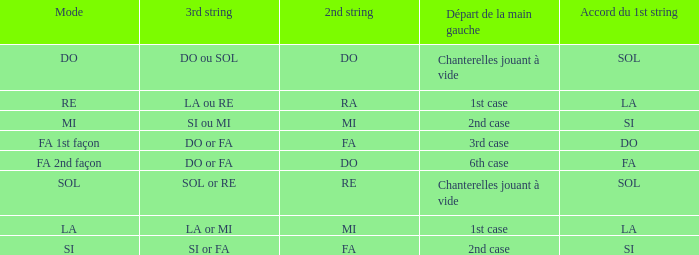For the 2nd string of Ra what is the Depart de la main gauche? 1st case. 